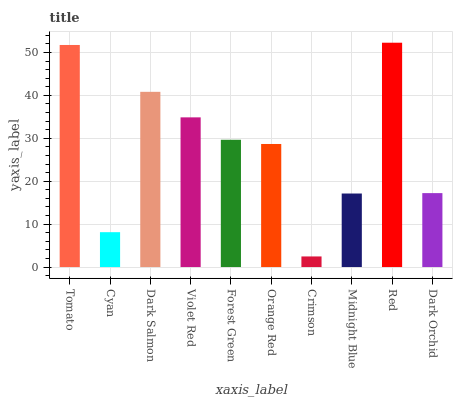Is Crimson the minimum?
Answer yes or no. Yes. Is Red the maximum?
Answer yes or no. Yes. Is Cyan the minimum?
Answer yes or no. No. Is Cyan the maximum?
Answer yes or no. No. Is Tomato greater than Cyan?
Answer yes or no. Yes. Is Cyan less than Tomato?
Answer yes or no. Yes. Is Cyan greater than Tomato?
Answer yes or no. No. Is Tomato less than Cyan?
Answer yes or no. No. Is Forest Green the high median?
Answer yes or no. Yes. Is Orange Red the low median?
Answer yes or no. Yes. Is Midnight Blue the high median?
Answer yes or no. No. Is Red the low median?
Answer yes or no. No. 